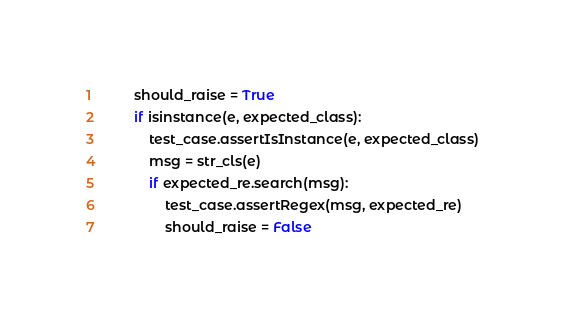<code> <loc_0><loc_0><loc_500><loc_500><_Python_>        should_raise = True
        if isinstance(e, expected_class):
            test_case.assertIsInstance(e, expected_class)
            msg = str_cls(e)
            if expected_re.search(msg):
                test_case.assertRegex(msg, expected_re)
                should_raise = False</code> 